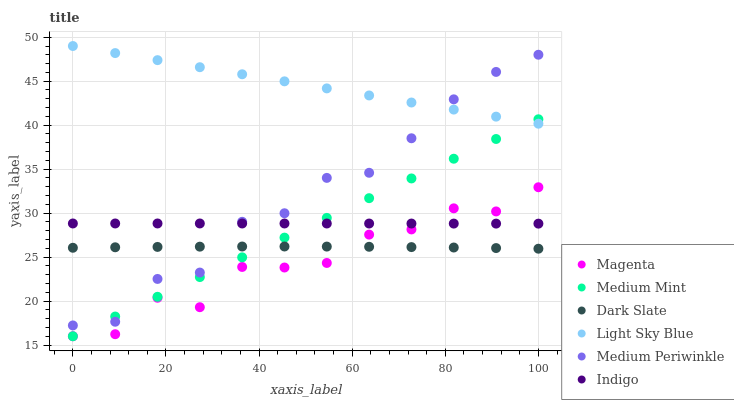Does Magenta have the minimum area under the curve?
Answer yes or no. Yes. Does Light Sky Blue have the maximum area under the curve?
Answer yes or no. Yes. Does Indigo have the minimum area under the curve?
Answer yes or no. No. Does Indigo have the maximum area under the curve?
Answer yes or no. No. Is Medium Mint the smoothest?
Answer yes or no. Yes. Is Magenta the roughest?
Answer yes or no. Yes. Is Indigo the smoothest?
Answer yes or no. No. Is Indigo the roughest?
Answer yes or no. No. Does Medium Mint have the lowest value?
Answer yes or no. Yes. Does Indigo have the lowest value?
Answer yes or no. No. Does Light Sky Blue have the highest value?
Answer yes or no. Yes. Does Indigo have the highest value?
Answer yes or no. No. Is Dark Slate less than Indigo?
Answer yes or no. Yes. Is Light Sky Blue greater than Dark Slate?
Answer yes or no. Yes. Does Medium Mint intersect Dark Slate?
Answer yes or no. Yes. Is Medium Mint less than Dark Slate?
Answer yes or no. No. Is Medium Mint greater than Dark Slate?
Answer yes or no. No. Does Dark Slate intersect Indigo?
Answer yes or no. No. 